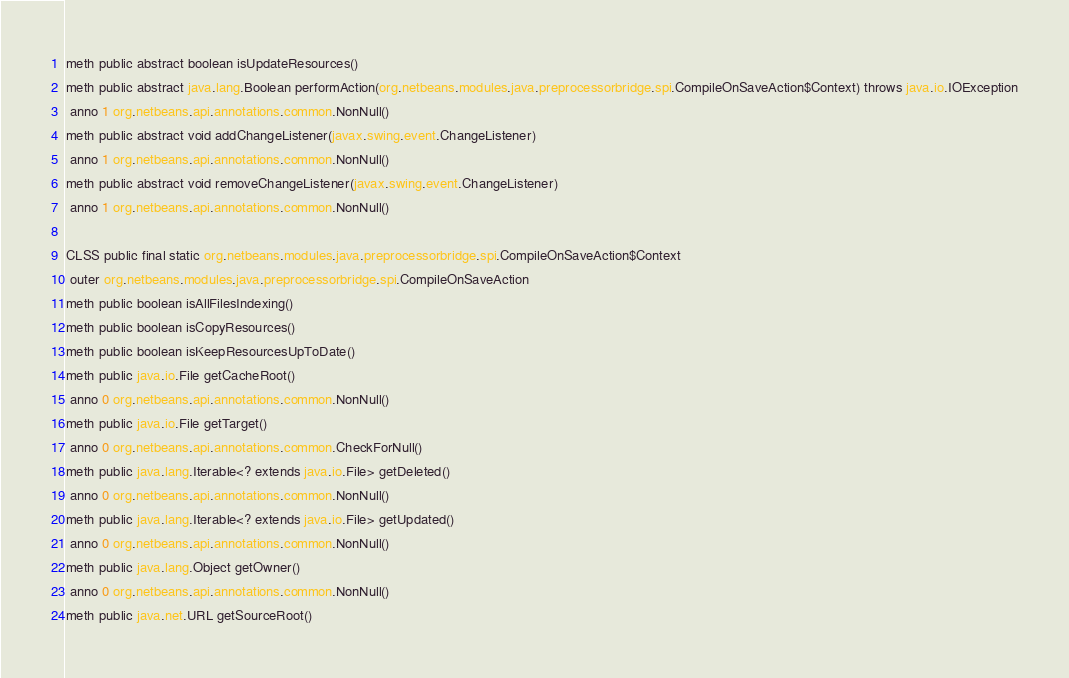<code> <loc_0><loc_0><loc_500><loc_500><_SML_>meth public abstract boolean isUpdateResources()
meth public abstract java.lang.Boolean performAction(org.netbeans.modules.java.preprocessorbridge.spi.CompileOnSaveAction$Context) throws java.io.IOException
 anno 1 org.netbeans.api.annotations.common.NonNull()
meth public abstract void addChangeListener(javax.swing.event.ChangeListener)
 anno 1 org.netbeans.api.annotations.common.NonNull()
meth public abstract void removeChangeListener(javax.swing.event.ChangeListener)
 anno 1 org.netbeans.api.annotations.common.NonNull()

CLSS public final static org.netbeans.modules.java.preprocessorbridge.spi.CompileOnSaveAction$Context
 outer org.netbeans.modules.java.preprocessorbridge.spi.CompileOnSaveAction
meth public boolean isAllFilesIndexing()
meth public boolean isCopyResources()
meth public boolean isKeepResourcesUpToDate()
meth public java.io.File getCacheRoot()
 anno 0 org.netbeans.api.annotations.common.NonNull()
meth public java.io.File getTarget()
 anno 0 org.netbeans.api.annotations.common.CheckForNull()
meth public java.lang.Iterable<? extends java.io.File> getDeleted()
 anno 0 org.netbeans.api.annotations.common.NonNull()
meth public java.lang.Iterable<? extends java.io.File> getUpdated()
 anno 0 org.netbeans.api.annotations.common.NonNull()
meth public java.lang.Object getOwner()
 anno 0 org.netbeans.api.annotations.common.NonNull()
meth public java.net.URL getSourceRoot()</code> 